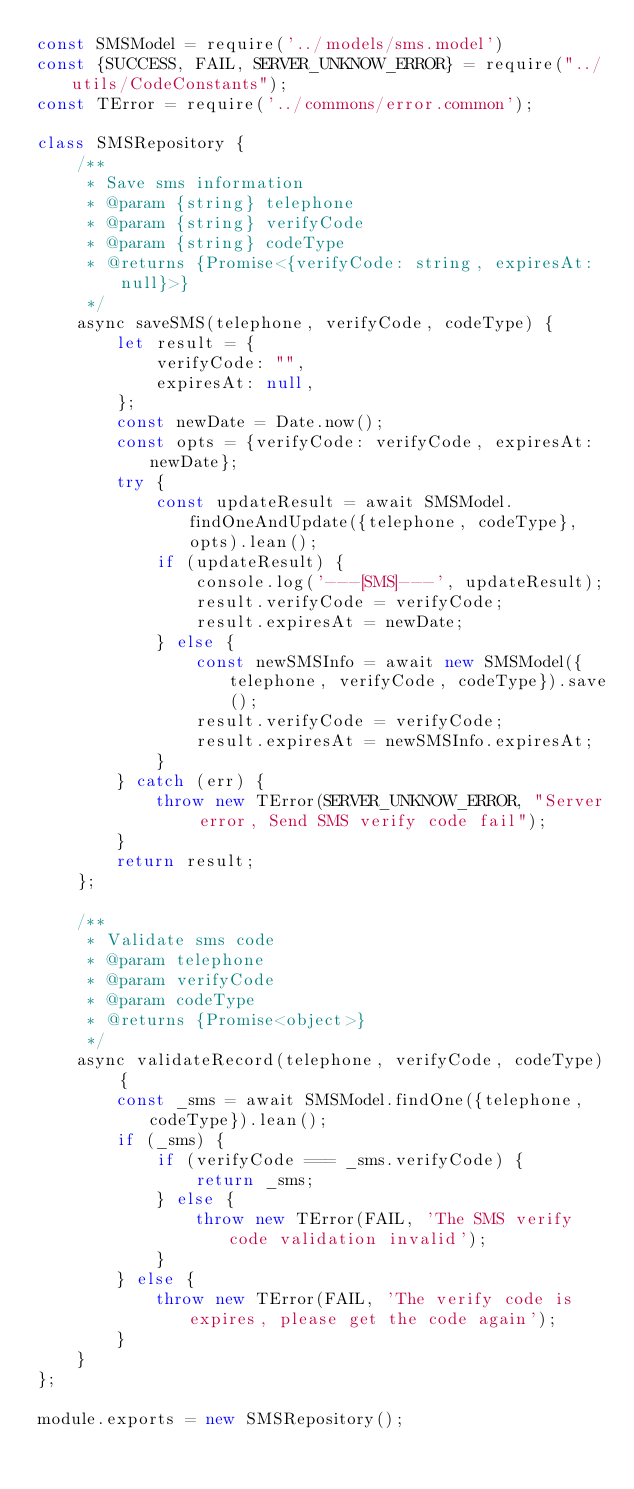Convert code to text. <code><loc_0><loc_0><loc_500><loc_500><_JavaScript_>const SMSModel = require('../models/sms.model')
const {SUCCESS, FAIL, SERVER_UNKNOW_ERROR} = require("../utils/CodeConstants");
const TError = require('../commons/error.common');

class SMSRepository {
    /**
     * Save sms information
     * @param {string} telephone
     * @param {string} verifyCode
     * @param {string} codeType
     * @returns {Promise<{verifyCode: string, expiresAt: null}>}
     */
    async saveSMS(telephone, verifyCode, codeType) {
        let result = {
            verifyCode: "",
            expiresAt: null,
        };
        const newDate = Date.now();
        const opts = {verifyCode: verifyCode, expiresAt: newDate};
        try {
            const updateResult = await SMSModel.findOneAndUpdate({telephone, codeType}, opts).lean();
            if (updateResult) {
                console.log('---[SMS]---', updateResult);
                result.verifyCode = verifyCode;
                result.expiresAt = newDate;
            } else {
                const newSMSInfo = await new SMSModel({telephone, verifyCode, codeType}).save();
                result.verifyCode = verifyCode;
                result.expiresAt = newSMSInfo.expiresAt;
            }
        } catch (err) {
            throw new TError(SERVER_UNKNOW_ERROR, "Server error, Send SMS verify code fail");
        }
        return result;
    };

    /**
     * Validate sms code
     * @param telephone
     * @param verifyCode
     * @param codeType
     * @returns {Promise<object>}
     */
    async validateRecord(telephone, verifyCode, codeType) {
        const _sms = await SMSModel.findOne({telephone, codeType}).lean();
        if (_sms) {
            if (verifyCode === _sms.verifyCode) {
                return _sms;
            } else {
                throw new TError(FAIL, 'The SMS verify code validation invalid');
            }
        } else {
            throw new TError(FAIL, 'The verify code is expires, please get the code again');
        }
    }
};

module.exports = new SMSRepository();
</code> 